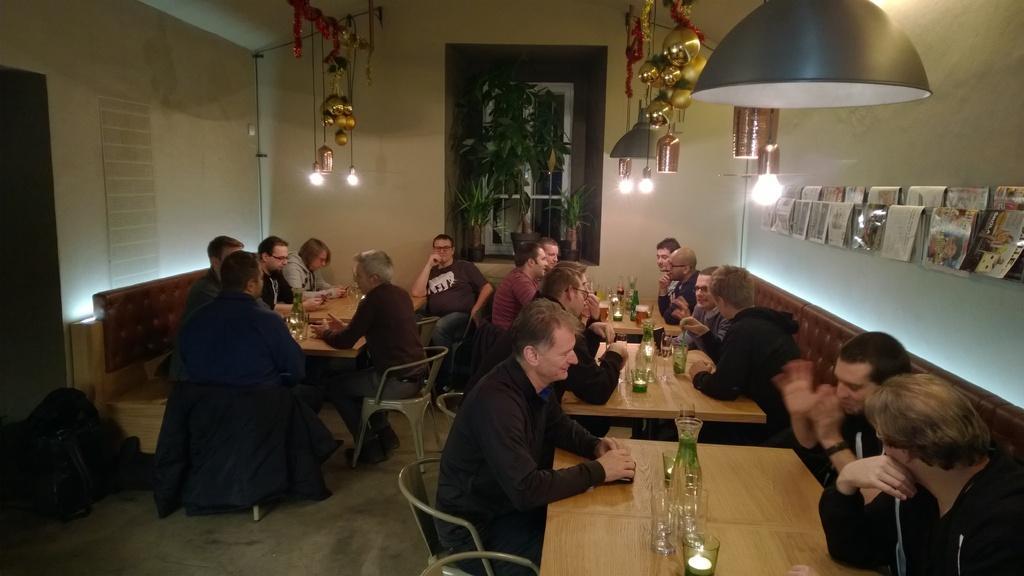How would you summarize this image in a sentence or two? In this image, there are some tables which are in yellow color, there are some people sitting on the chairs which around the table, in the top there is a light which is in ash color hanging on the roof , in the right side there is a wall which is white color there are some books hanging on the ropes, in the middle there is a window and there are some green color plants. 